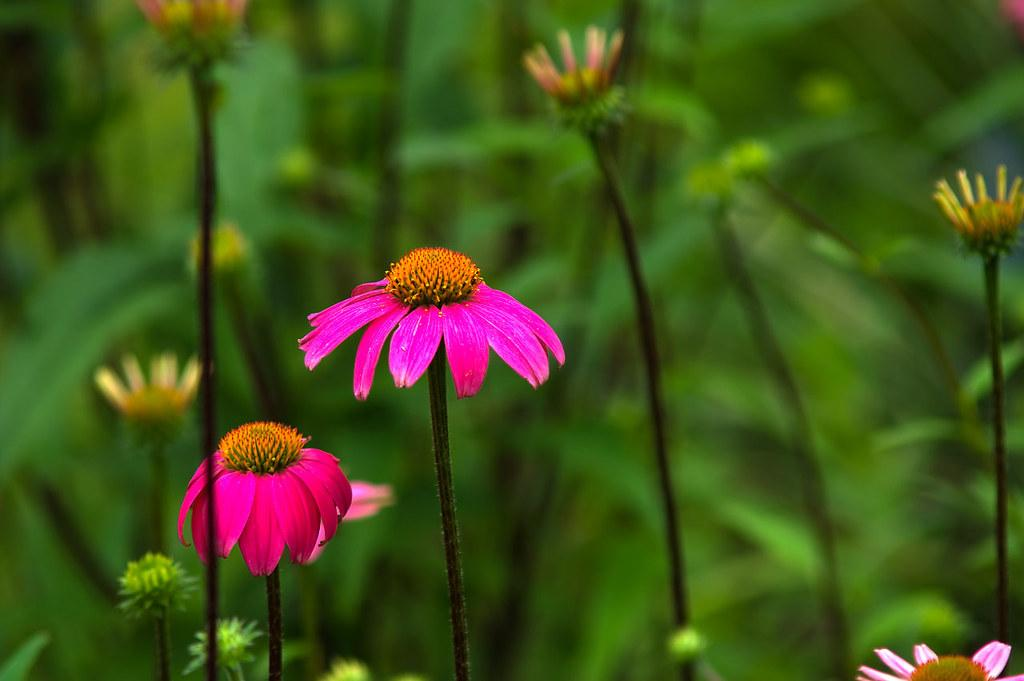What type of living organisms can be seen in the image? There are flowers and plants in the image. Can you describe the plants in the image? The plants in the image are not specified, but they are present alongside the flowers. What type of lumber is being used to cover the flowers in the image? There is no lumber present in the image, and the flowers are not covered. 